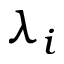Convert formula to latex. <formula><loc_0><loc_0><loc_500><loc_500>\lambda _ { i }</formula> 